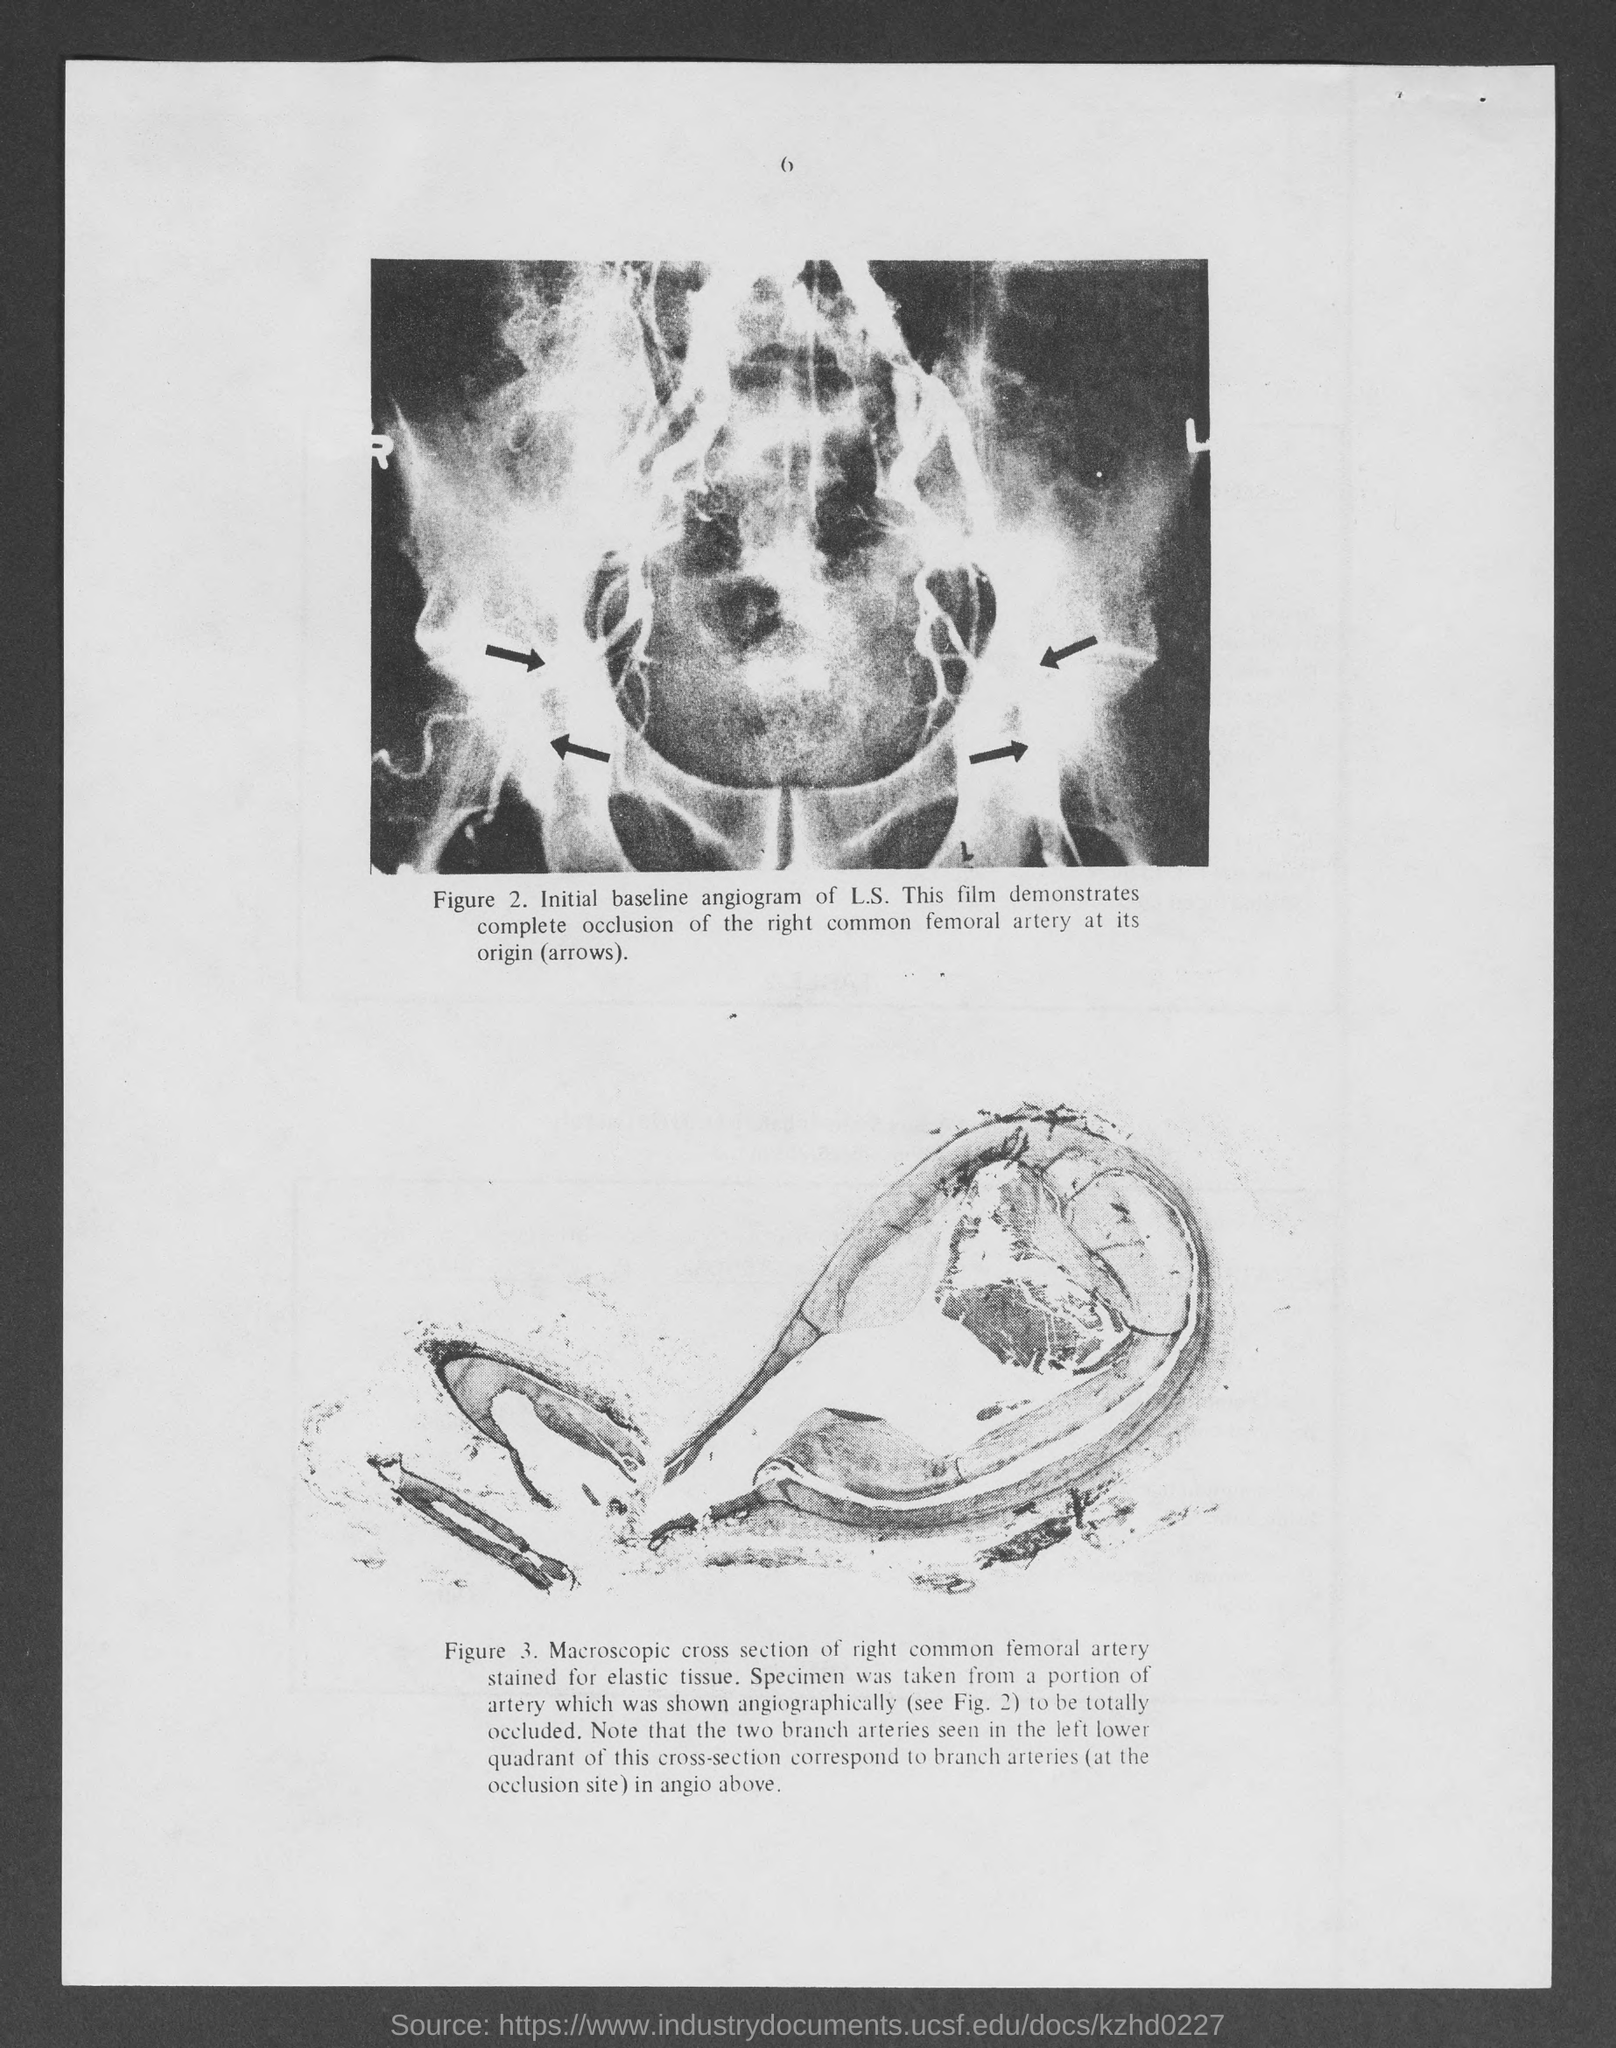Indicate a few pertinent items in this graphic. The number at the top of the page is 6. 